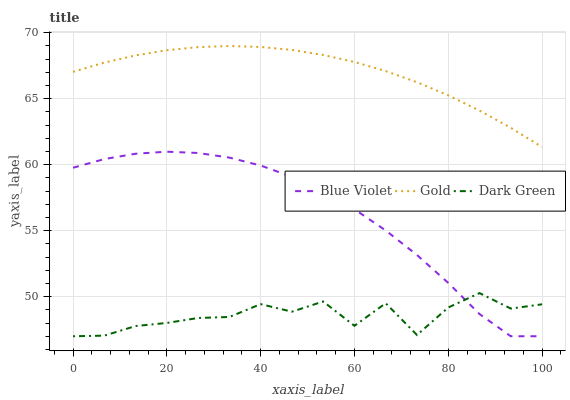Does Dark Green have the minimum area under the curve?
Answer yes or no. Yes. Does Gold have the maximum area under the curve?
Answer yes or no. Yes. Does Blue Violet have the minimum area under the curve?
Answer yes or no. No. Does Blue Violet have the maximum area under the curve?
Answer yes or no. No. Is Gold the smoothest?
Answer yes or no. Yes. Is Dark Green the roughest?
Answer yes or no. Yes. Is Blue Violet the smoothest?
Answer yes or no. No. Is Blue Violet the roughest?
Answer yes or no. No. Does Blue Violet have the highest value?
Answer yes or no. No. Is Dark Green less than Gold?
Answer yes or no. Yes. Is Gold greater than Blue Violet?
Answer yes or no. Yes. Does Dark Green intersect Gold?
Answer yes or no. No. 